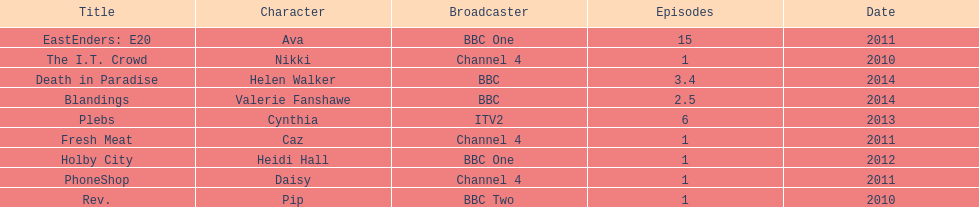Blandings and death in paradise both aired on which broadcaster? BBC. 